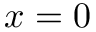Convert formula to latex. <formula><loc_0><loc_0><loc_500><loc_500>x = 0</formula> 